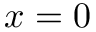Convert formula to latex. <formula><loc_0><loc_0><loc_500><loc_500>x = 0</formula> 